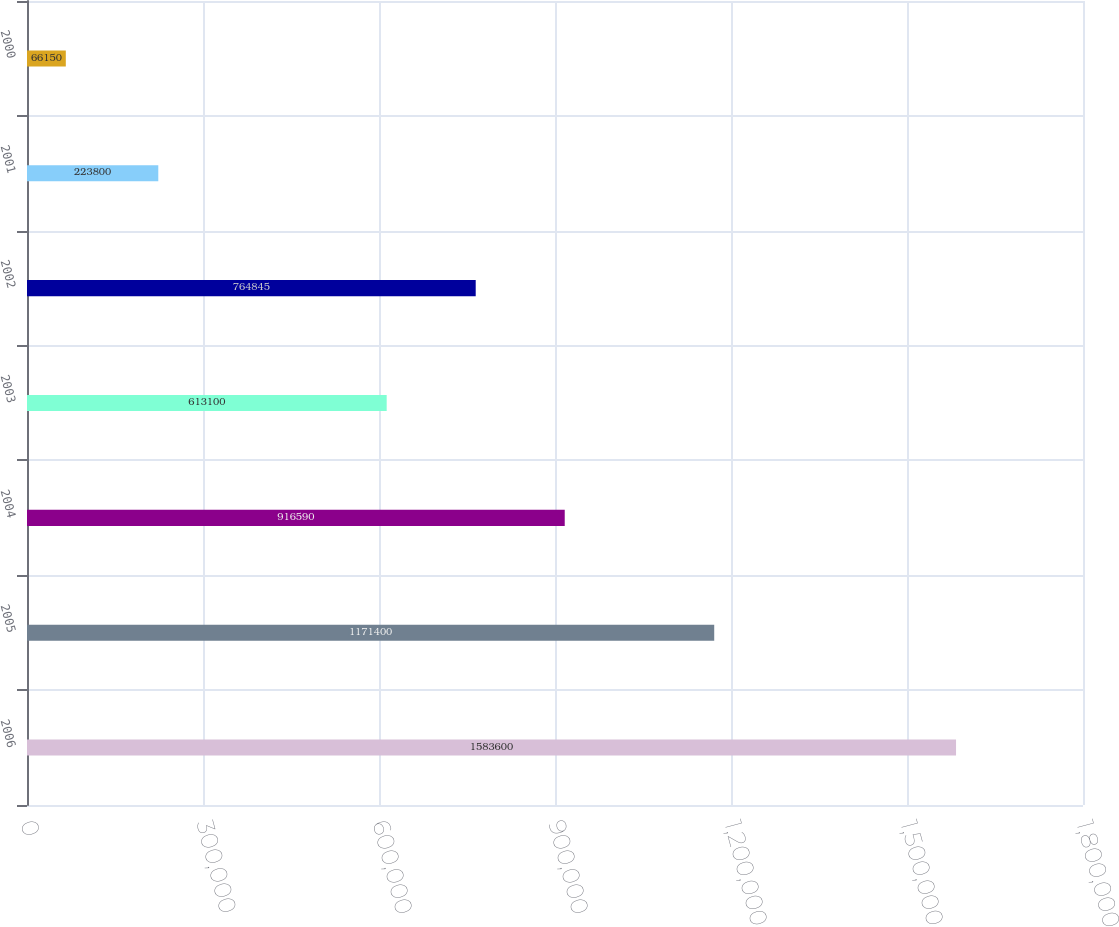Convert chart to OTSL. <chart><loc_0><loc_0><loc_500><loc_500><bar_chart><fcel>2006<fcel>2005<fcel>2004<fcel>2003<fcel>2002<fcel>2001<fcel>2000<nl><fcel>1.5836e+06<fcel>1.1714e+06<fcel>916590<fcel>613100<fcel>764845<fcel>223800<fcel>66150<nl></chart> 